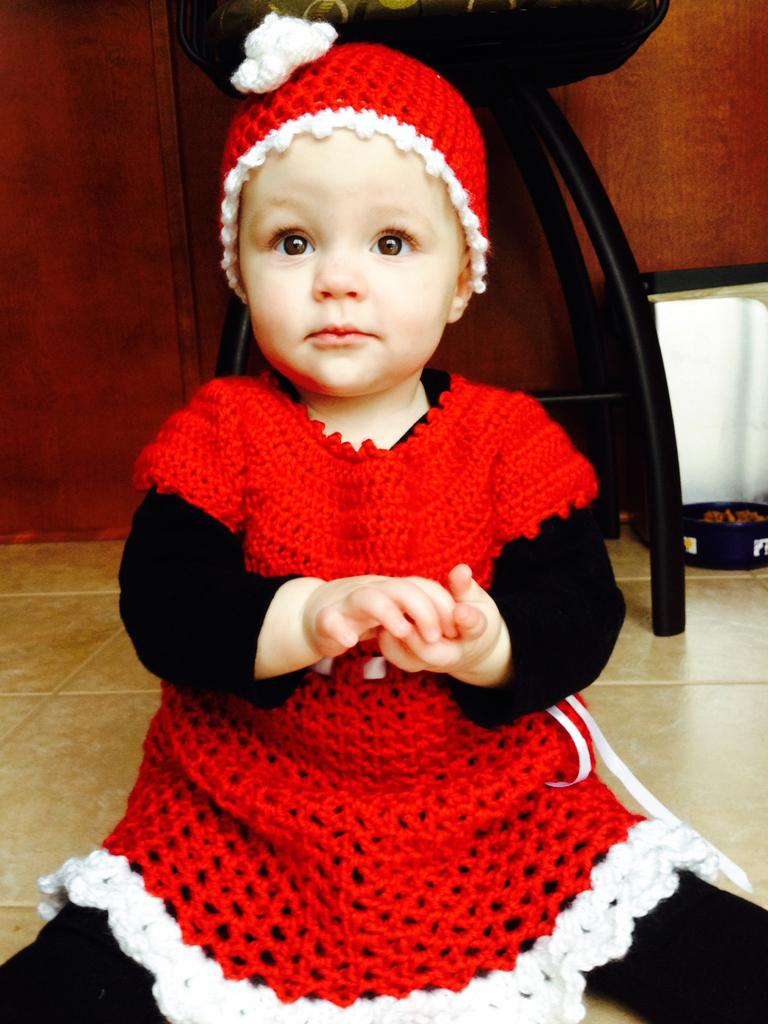Who is the main subject in the image? There is a girl in the image. What is the girl doing in the image? The girl is sitting on the floor. What can be seen in the background of the image? There is a chair, objects, and a wall in the background of the image. What type of impulse can be seen affecting the girl in the image? There is no indication of any impulse affecting the girl in the image. What type of writer is depicted in the image? There is no writer depicted in the image; it features a girl sitting on the floor. 